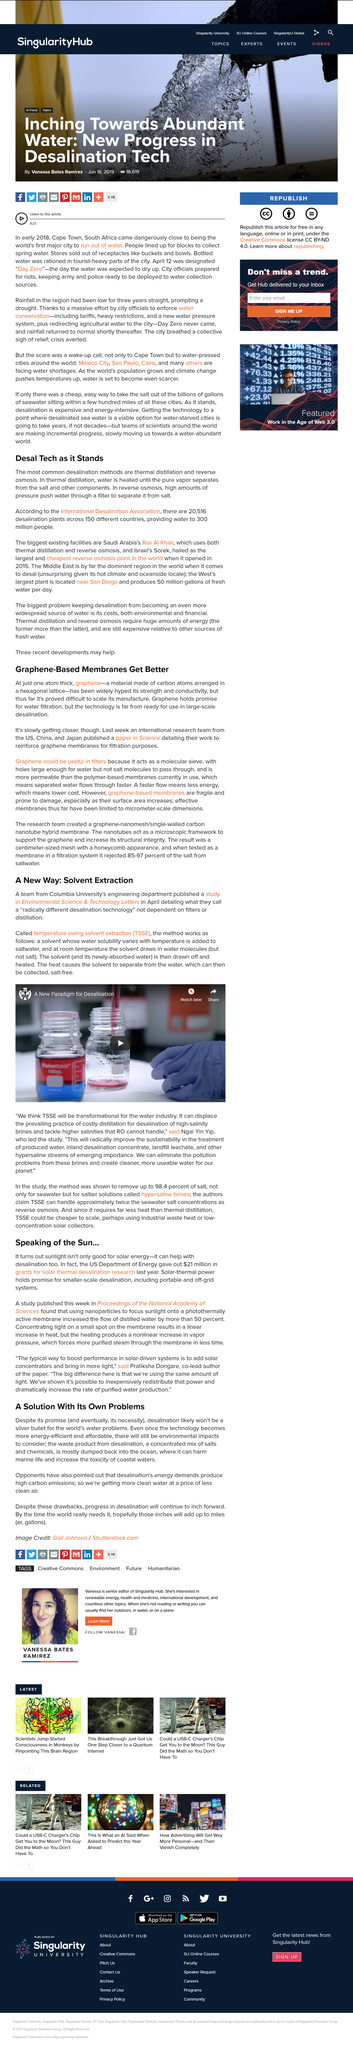List a handful of essential elements in this visual. This page discusses the topic of Graphene-Based membranes. The widespread adoption of desalination technology is hindered by both environmental and financial costs, preventing it from becoming a more prevalent solution to water scarcity. The two desalination processes of thermal distillation and reverse osmosis provide water for 300 million people across the world. The Sorek plant in Israel is hailed as the largest and cheapest reverse osmosis desalination plant in the world. The US Department of Energy awarded $21 million in grants for solar-thermal desalination research. 